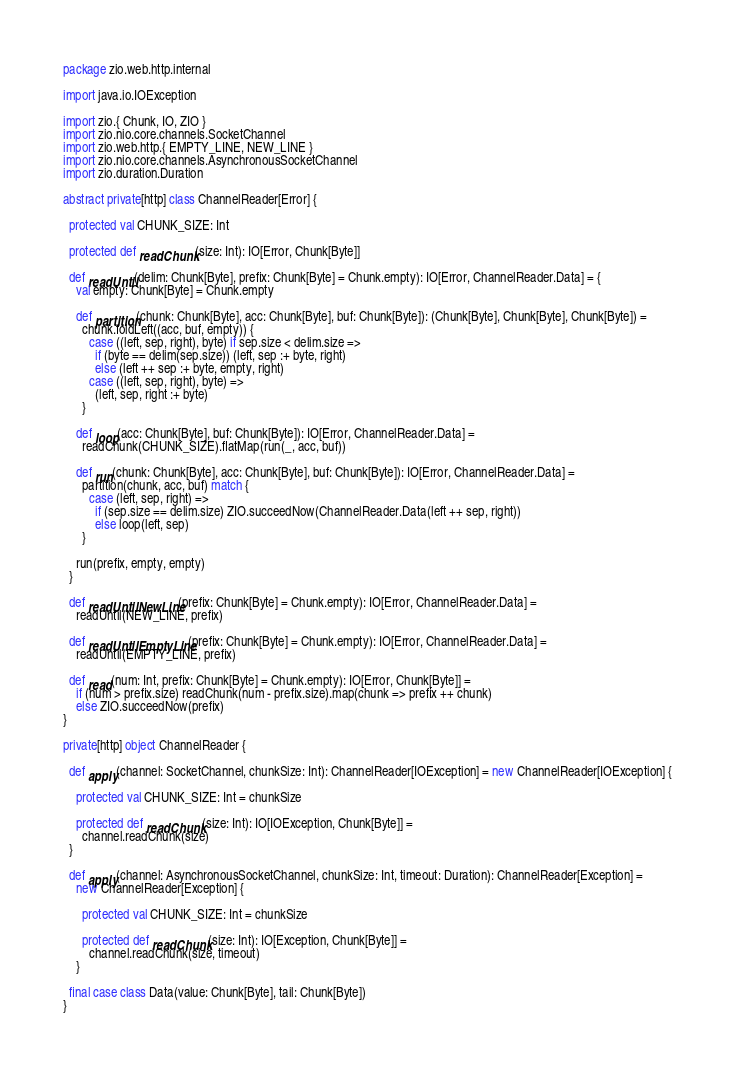<code> <loc_0><loc_0><loc_500><loc_500><_Scala_>package zio.web.http.internal

import java.io.IOException

import zio.{ Chunk, IO, ZIO }
import zio.nio.core.channels.SocketChannel
import zio.web.http.{ EMPTY_LINE, NEW_LINE }
import zio.nio.core.channels.AsynchronousSocketChannel
import zio.duration.Duration

abstract private[http] class ChannelReader[Error] {

  protected val CHUNK_SIZE: Int

  protected def readChunk(size: Int): IO[Error, Chunk[Byte]]

  def readUntil(delim: Chunk[Byte], prefix: Chunk[Byte] = Chunk.empty): IO[Error, ChannelReader.Data] = {
    val empty: Chunk[Byte] = Chunk.empty

    def partition(chunk: Chunk[Byte], acc: Chunk[Byte], buf: Chunk[Byte]): (Chunk[Byte], Chunk[Byte], Chunk[Byte]) =
      chunk.foldLeft((acc, buf, empty)) {
        case ((left, sep, right), byte) if sep.size < delim.size =>
          if (byte == delim(sep.size)) (left, sep :+ byte, right)
          else (left ++ sep :+ byte, empty, right)
        case ((left, sep, right), byte) =>
          (left, sep, right :+ byte)
      }

    def loop(acc: Chunk[Byte], buf: Chunk[Byte]): IO[Error, ChannelReader.Data] =
      readChunk(CHUNK_SIZE).flatMap(run(_, acc, buf))

    def run(chunk: Chunk[Byte], acc: Chunk[Byte], buf: Chunk[Byte]): IO[Error, ChannelReader.Data] =
      partition(chunk, acc, buf) match {
        case (left, sep, right) =>
          if (sep.size == delim.size) ZIO.succeedNow(ChannelReader.Data(left ++ sep, right))
          else loop(left, sep)
      }

    run(prefix, empty, empty)
  }

  def readUntilNewLine(prefix: Chunk[Byte] = Chunk.empty): IO[Error, ChannelReader.Data] =
    readUntil(NEW_LINE, prefix)

  def readUntilEmptyLine(prefix: Chunk[Byte] = Chunk.empty): IO[Error, ChannelReader.Data] =
    readUntil(EMPTY_LINE, prefix)

  def read(num: Int, prefix: Chunk[Byte] = Chunk.empty): IO[Error, Chunk[Byte]] =
    if (num > prefix.size) readChunk(num - prefix.size).map(chunk => prefix ++ chunk)
    else ZIO.succeedNow(prefix)
}

private[http] object ChannelReader {

  def apply(channel: SocketChannel, chunkSize: Int): ChannelReader[IOException] = new ChannelReader[IOException] {

    protected val CHUNK_SIZE: Int = chunkSize

    protected def readChunk(size: Int): IO[IOException, Chunk[Byte]] =
      channel.readChunk(size)
  }

  def apply(channel: AsynchronousSocketChannel, chunkSize: Int, timeout: Duration): ChannelReader[Exception] =
    new ChannelReader[Exception] {

      protected val CHUNK_SIZE: Int = chunkSize

      protected def readChunk(size: Int): IO[Exception, Chunk[Byte]] =
        channel.readChunk(size, timeout)
    }

  final case class Data(value: Chunk[Byte], tail: Chunk[Byte])
}
</code> 